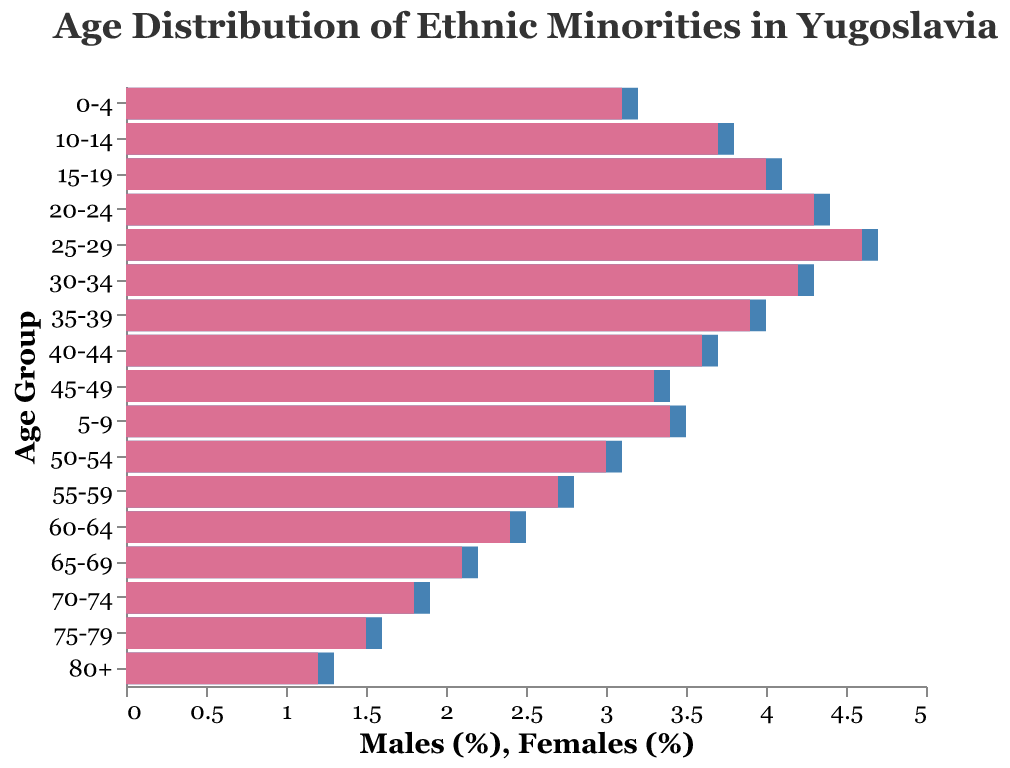What is the title of the figure? The title is usually positioned at the top of the figure. In this case, it reads "Age Distribution of Ethnic Minorities in Yugoslavia."
Answer: Age Distribution of Ethnic Minorities in Yugoslavia What are the color codes representing males and females? The males are represented by a blue color, while the females are represented by a pink color.
Answer: Blue for males, pink for females Which age group has the highest percentage of males? By looking at the length of the bars, the age group 25-29 has the highest percentage of males, indicated by the longest blue bar.
Answer: 25-29 How does the percentage of females aged 0-4 compare to the percentage of males in the same age group? The females aged 0-4 have a slightly lower percentage compared to the males, which can be observed by the slightly shorter pink bar.
Answer: Females have a slightly lower percentage What's the overall trend in population as the age groups increase? There is a general decreasing trend in the percentage of both males and females as the age groups increase, indicated by the progressively shorter bars as we move from younger to older age groups.
Answer: Decreasing trend What is the approximate difference in percentage between males and females in the age group 80+? For the age group 80+, the percentage of males is -1.3, and for females, it's 1.2. The absolute difference is
Answer: 1.3 Compare the percentage of males and females in the age group 15-19. Which gender has a higher percentage, and by how much? For the age group 15-19, the percentage of males is -4.1, and for females, it's 4.0. Therefore, males have a 0.1% higher percentage than females.
Answer: Males by 0.1% What's the trend in the difference between males and females as the age groups increase? The difference between males and females is roughly similar initially but starts to decline gradually, showing a significant decrease in disparity in the older age groups.
Answer: Decreasing difference Is the percentage of females in the age group 35-39 higher or lower than in the age group 40-44? The percentage of females in the age group 35-39 is slightly higher (3.9%) compared to the age group 40-44 (3.6%).
Answer: Higher in 35-39 Which age group shows the lowest percentage for both males and females, and what is that percentage? The age group 80+ has the lowest percentage for both males (1.3%) and females (1.2%).
Answer: 80+ % 